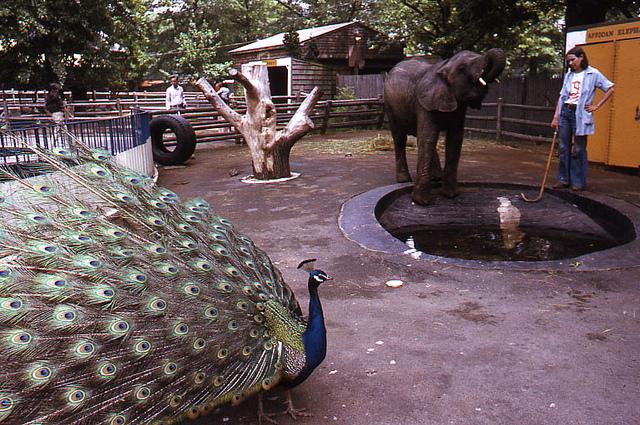What is the name of the bird on the bottom left?
Be succinct. Peacock. How old is this elephant?
Quick response, please. 1. How many species are in this picture?
Be succinct. 3. 